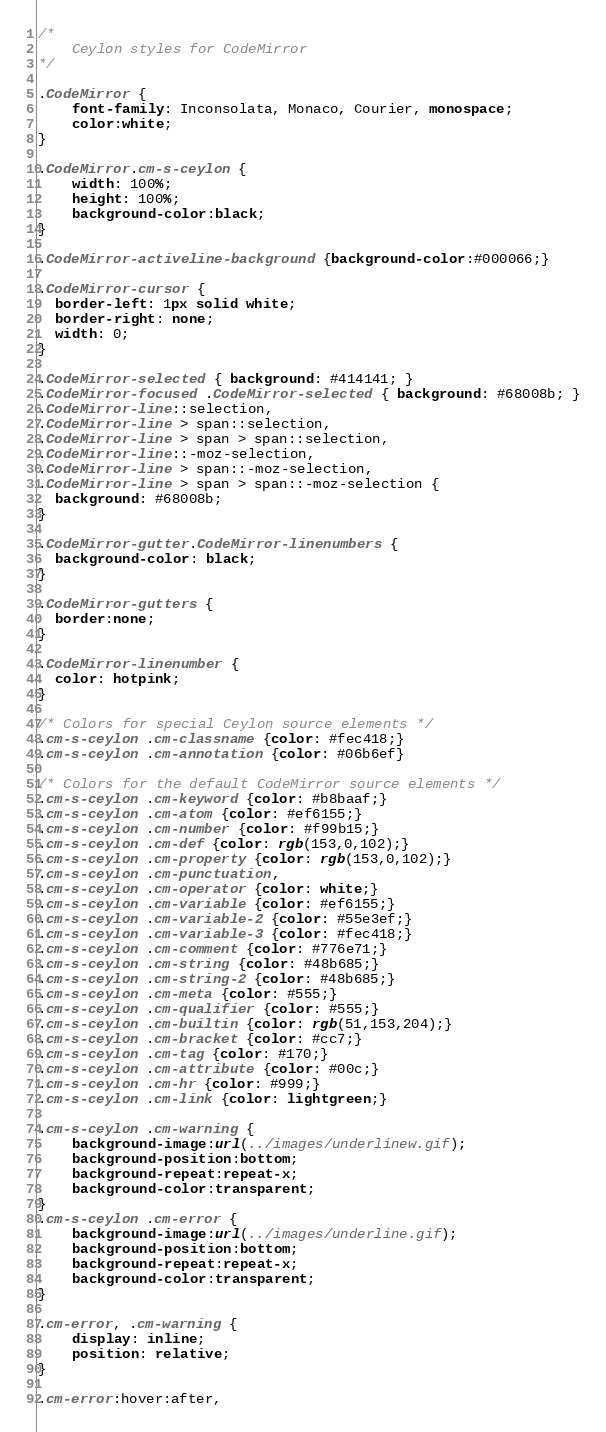Convert code to text. <code><loc_0><loc_0><loc_500><loc_500><_CSS_>/*
    Ceylon styles for CodeMirror
*/

.CodeMirror {
    font-family: Inconsolata, Monaco, Courier, monospace;
    color:white;
}

.CodeMirror.cm-s-ceylon {
    width: 100%;
    height: 100%;
    background-color:black;
}

.CodeMirror-activeline-background {background-color:#000066;}

.CodeMirror-cursor {
  border-left: 1px solid white;
  border-right: none;
  width: 0;
}

.CodeMirror-selected { background: #414141; }
.CodeMirror-focused .CodeMirror-selected { background: #68008b; }
.CodeMirror-line::selection, 
.CodeMirror-line > span::selection, 
.CodeMirror-line > span > span::selection,
.CodeMirror-line::-moz-selection,
.CodeMirror-line > span::-moz-selection, 
.CodeMirror-line > span > span::-moz-selection {
  background: #68008b;
}

.CodeMirror-gutter.CodeMirror-linenumbers {
  background-color: black;
}

.CodeMirror-gutters {
  border:none;
}

.CodeMirror-linenumber {
  color: hotpink;
}

/* Colors for special Ceylon source elements */
.cm-s-ceylon .cm-classname {color: #fec418;}
.cm-s-ceylon .cm-annotation {color: #06b6ef}

/* Colors for the default CodeMirror source elements */
.cm-s-ceylon .cm-keyword {color: #b8baaf;}
.cm-s-ceylon .cm-atom {color: #ef6155;}
.cm-s-ceylon .cm-number {color: #f99b15;}
.cm-s-ceylon .cm-def {color: rgb(153,0,102);}
.cm-s-ceylon .cm-property {color: rgb(153,0,102);}
.cm-s-ceylon .cm-punctuation,
.cm-s-ceylon .cm-operator {color: white;}
.cm-s-ceylon .cm-variable {color: #ef6155;}
.cm-s-ceylon .cm-variable-2 {color: #55e3ef;}
.cm-s-ceylon .cm-variable-3 {color: #fec418;}
.cm-s-ceylon .cm-comment {color: #776e71;}
.cm-s-ceylon .cm-string {color: #48b685;}
.cm-s-ceylon .cm-string-2 {color: #48b685;}
.cm-s-ceylon .cm-meta {color: #555;}
.cm-s-ceylon .cm-qualifier {color: #555;}
.cm-s-ceylon .cm-builtin {color: rgb(51,153,204);}
.cm-s-ceylon .cm-bracket {color: #cc7;}
.cm-s-ceylon .cm-tag {color: #170;}
.cm-s-ceylon .cm-attribute {color: #00c;}
.cm-s-ceylon .cm-hr {color: #999;}
.cm-s-ceylon .cm-link {color: lightgreen;}

.cm-s-ceylon .cm-warning {
    background-image:url(../images/underlinew.gif);
    background-position:bottom;
    background-repeat:repeat-x;
    background-color:transparent;
}
.cm-s-ceylon .cm-error {
    background-image:url(../images/underline.gif);
    background-position:bottom;
    background-repeat:repeat-x;
    background-color:transparent;
}

.cm-error, .cm-warning {
    display: inline;
    position: relative;
}

.cm-error:hover:after, </code> 